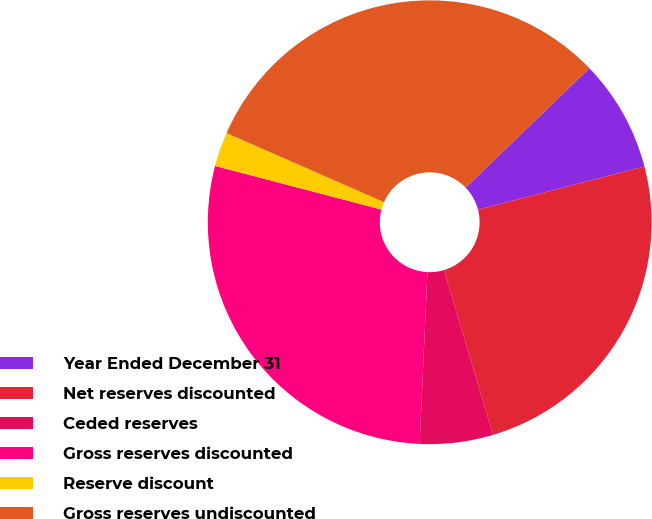Convert chart to OTSL. <chart><loc_0><loc_0><loc_500><loc_500><pie_chart><fcel>Year Ended December 31<fcel>Net reserves discounted<fcel>Ceded reserves<fcel>Gross reserves discounted<fcel>Reserve discount<fcel>Gross reserves undiscounted<nl><fcel>8.17%<fcel>24.43%<fcel>5.33%<fcel>28.36%<fcel>2.5%<fcel>31.2%<nl></chart> 